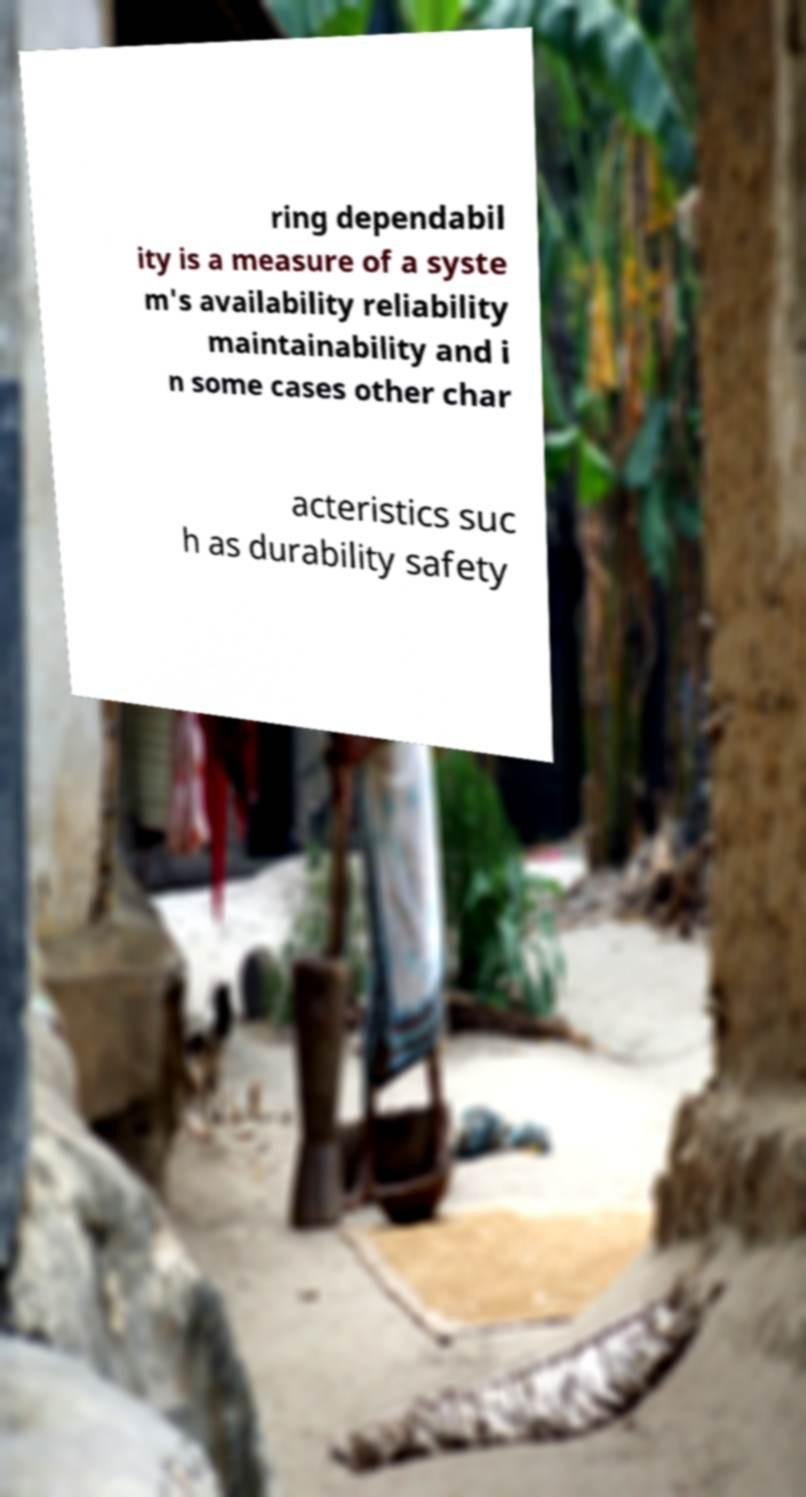Could you extract and type out the text from this image? ring dependabil ity is a measure of a syste m's availability reliability maintainability and i n some cases other char acteristics suc h as durability safety 